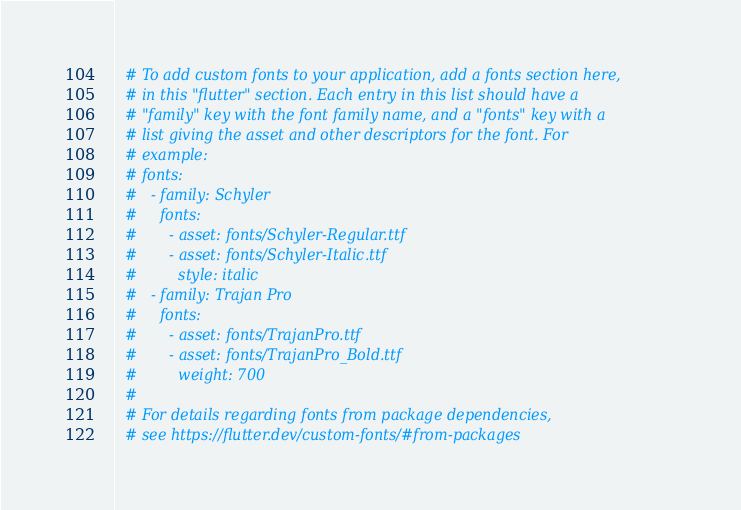Convert code to text. <code><loc_0><loc_0><loc_500><loc_500><_YAML_>
  # To add custom fonts to your application, add a fonts section here,
  # in this "flutter" section. Each entry in this list should have a
  # "family" key with the font family name, and a "fonts" key with a
  # list giving the asset and other descriptors for the font. For
  # example:
  # fonts:
  #   - family: Schyler
  #     fonts:
  #       - asset: fonts/Schyler-Regular.ttf
  #       - asset: fonts/Schyler-Italic.ttf
  #         style: italic
  #   - family: Trajan Pro
  #     fonts:
  #       - asset: fonts/TrajanPro.ttf
  #       - asset: fonts/TrajanPro_Bold.ttf
  #         weight: 700
  #
  # For details regarding fonts from package dependencies,
  # see https://flutter.dev/custom-fonts/#from-packages
</code> 